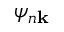<formula> <loc_0><loc_0><loc_500><loc_500>\psi _ { n k }</formula> 